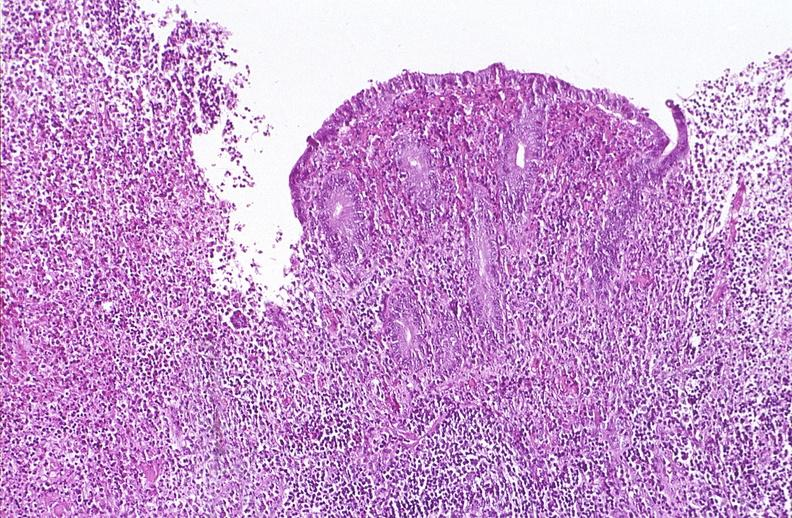where is this from?
Answer the question using a single word or phrase. Gastrointestinal system 